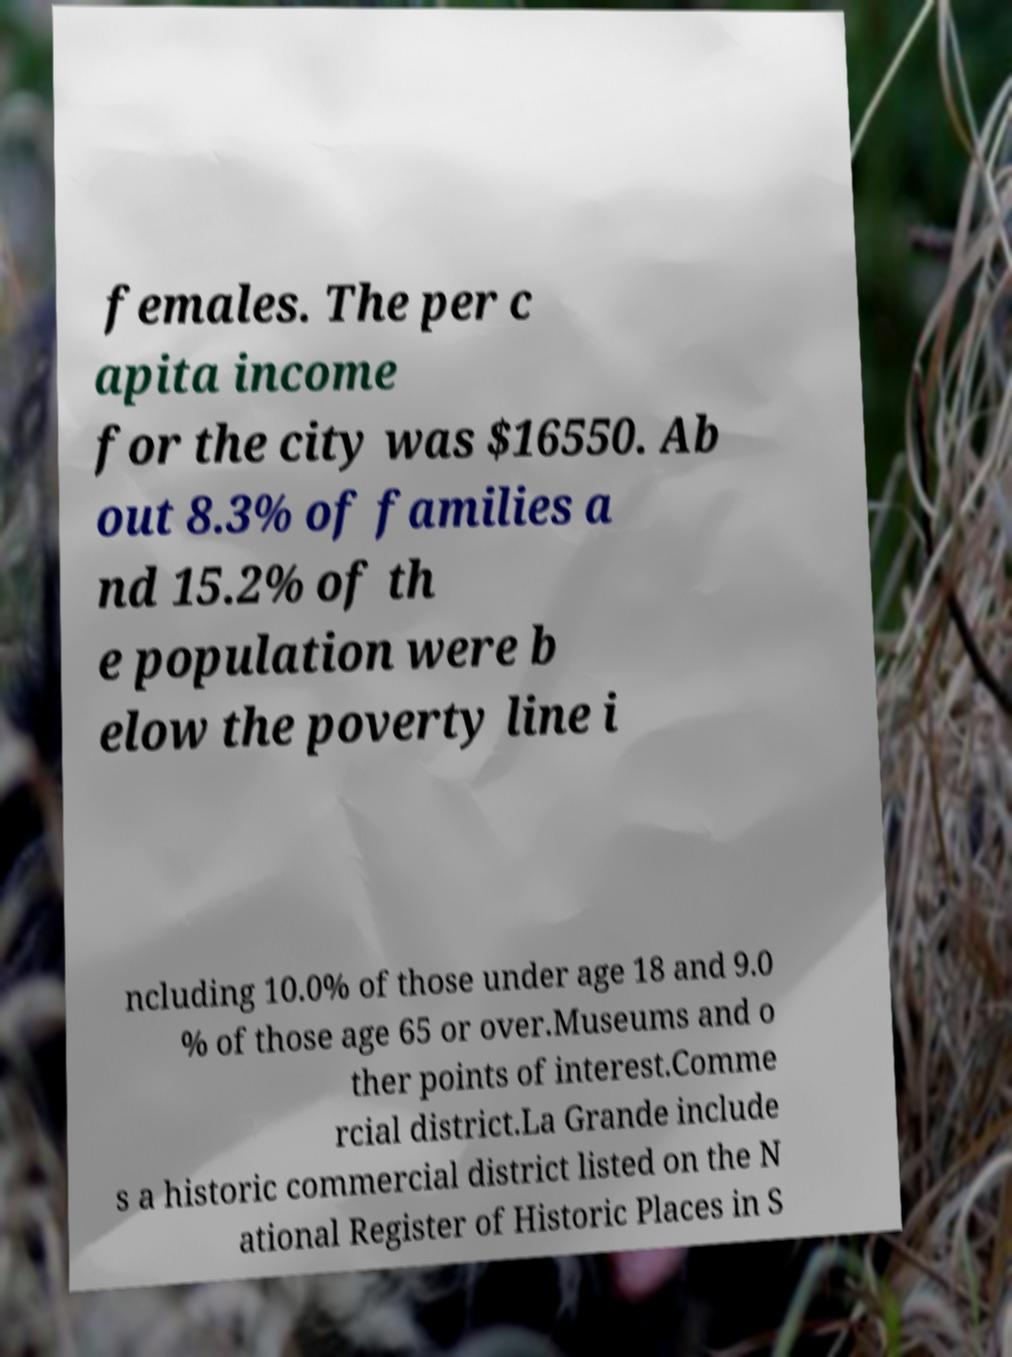I need the written content from this picture converted into text. Can you do that? females. The per c apita income for the city was $16550. Ab out 8.3% of families a nd 15.2% of th e population were b elow the poverty line i ncluding 10.0% of those under age 18 and 9.0 % of those age 65 or over.Museums and o ther points of interest.Comme rcial district.La Grande include s a historic commercial district listed on the N ational Register of Historic Places in S 